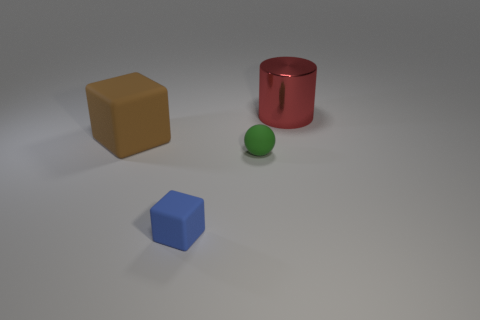There is a big object to the right of the big thing in front of the big red object; what is it made of? The big object to the right, which appears in front of the big red cylinder, is likely made of metal, given its reflective surface and lustrous finish which is characteristic of metallic objects. 